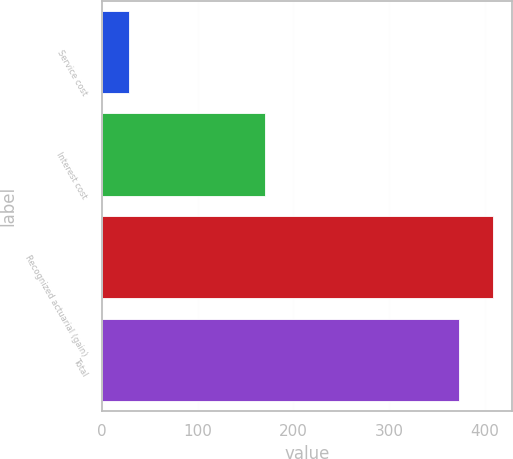<chart> <loc_0><loc_0><loc_500><loc_500><bar_chart><fcel>Service cost<fcel>Interest cost<fcel>Recognized actuarial (gain)<fcel>Total<nl><fcel>28<fcel>170<fcel>407.9<fcel>373<nl></chart> 